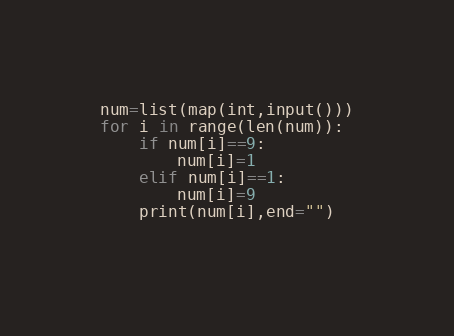Convert code to text. <code><loc_0><loc_0><loc_500><loc_500><_Python_>num=list(map(int,input()))
for i in range(len(num)):
    if num[i]==9:
        num[i]=1
    elif num[i]==1:
        num[i]=9 
    print(num[i],end="")
    </code> 